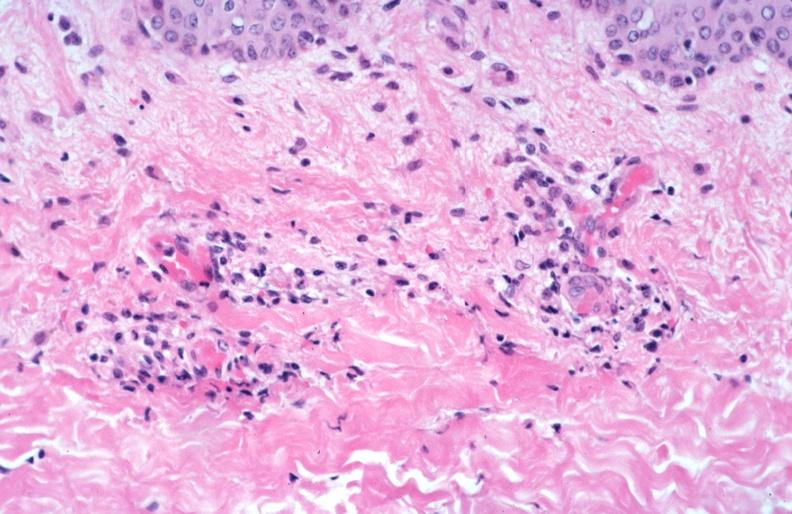what spotted fever, vasculitis?
Answer the question using a single word or phrase. Rocky mountain 